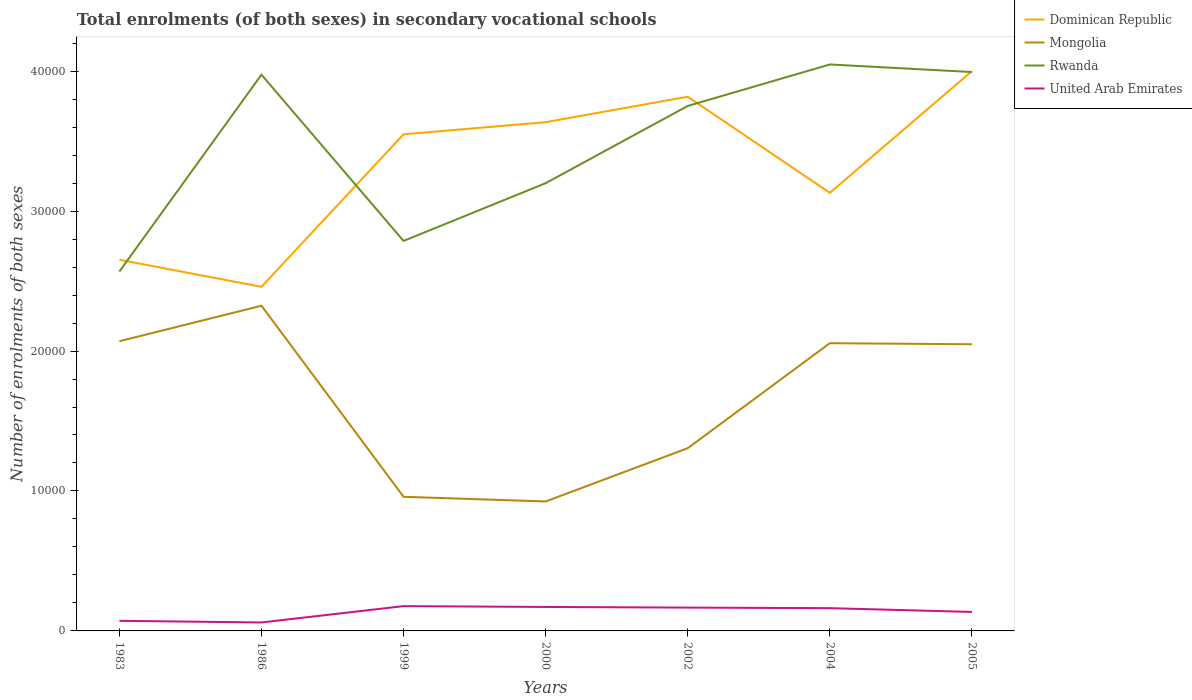How many different coloured lines are there?
Your answer should be very brief. 4. Is the number of lines equal to the number of legend labels?
Provide a short and direct response. Yes. Across all years, what is the maximum number of enrolments in secondary schools in Rwanda?
Offer a terse response. 2.57e+04. In which year was the number of enrolments in secondary schools in Rwanda maximum?
Give a very brief answer. 1983. What is the total number of enrolments in secondary schools in United Arab Emirates in the graph?
Your answer should be compact. 270. What is the difference between the highest and the second highest number of enrolments in secondary schools in Mongolia?
Make the answer very short. 1.40e+04. What is the difference between the highest and the lowest number of enrolments in secondary schools in Mongolia?
Your response must be concise. 4. How many lines are there?
Provide a succinct answer. 4. Are the values on the major ticks of Y-axis written in scientific E-notation?
Offer a terse response. No. Does the graph contain any zero values?
Keep it short and to the point. No. Where does the legend appear in the graph?
Give a very brief answer. Top right. How many legend labels are there?
Your answer should be compact. 4. How are the legend labels stacked?
Offer a terse response. Vertical. What is the title of the graph?
Your response must be concise. Total enrolments (of both sexes) in secondary vocational schools. What is the label or title of the X-axis?
Your answer should be compact. Years. What is the label or title of the Y-axis?
Provide a succinct answer. Number of enrolments of both sexes. What is the Number of enrolments of both sexes in Dominican Republic in 1983?
Give a very brief answer. 2.65e+04. What is the Number of enrolments of both sexes of Mongolia in 1983?
Make the answer very short. 2.07e+04. What is the Number of enrolments of both sexes of Rwanda in 1983?
Provide a short and direct response. 2.57e+04. What is the Number of enrolments of both sexes of United Arab Emirates in 1983?
Provide a succinct answer. 722. What is the Number of enrolments of both sexes of Dominican Republic in 1986?
Ensure brevity in your answer.  2.46e+04. What is the Number of enrolments of both sexes of Mongolia in 1986?
Your answer should be very brief. 2.32e+04. What is the Number of enrolments of both sexes in Rwanda in 1986?
Your response must be concise. 3.97e+04. What is the Number of enrolments of both sexes in United Arab Emirates in 1986?
Keep it short and to the point. 604. What is the Number of enrolments of both sexes in Dominican Republic in 1999?
Make the answer very short. 3.55e+04. What is the Number of enrolments of both sexes of Mongolia in 1999?
Your answer should be very brief. 9584. What is the Number of enrolments of both sexes of Rwanda in 1999?
Your answer should be very brief. 2.79e+04. What is the Number of enrolments of both sexes of United Arab Emirates in 1999?
Your answer should be compact. 1772. What is the Number of enrolments of both sexes in Dominican Republic in 2000?
Your response must be concise. 3.64e+04. What is the Number of enrolments of both sexes in Mongolia in 2000?
Keep it short and to the point. 9251. What is the Number of enrolments of both sexes in Rwanda in 2000?
Your answer should be very brief. 3.20e+04. What is the Number of enrolments of both sexes in United Arab Emirates in 2000?
Keep it short and to the point. 1713. What is the Number of enrolments of both sexes in Dominican Republic in 2002?
Your answer should be very brief. 3.82e+04. What is the Number of enrolments of both sexes of Mongolia in 2002?
Provide a succinct answer. 1.31e+04. What is the Number of enrolments of both sexes of Rwanda in 2002?
Keep it short and to the point. 3.75e+04. What is the Number of enrolments of both sexes in United Arab Emirates in 2002?
Ensure brevity in your answer.  1667. What is the Number of enrolments of both sexes in Dominican Republic in 2004?
Provide a succinct answer. 3.13e+04. What is the Number of enrolments of both sexes in Mongolia in 2004?
Offer a terse response. 2.06e+04. What is the Number of enrolments of both sexes in Rwanda in 2004?
Provide a short and direct response. 4.05e+04. What is the Number of enrolments of both sexes of United Arab Emirates in 2004?
Provide a succinct answer. 1627. What is the Number of enrolments of both sexes of Dominican Republic in 2005?
Make the answer very short. 4.00e+04. What is the Number of enrolments of both sexes of Mongolia in 2005?
Provide a short and direct response. 2.05e+04. What is the Number of enrolments of both sexes in Rwanda in 2005?
Offer a terse response. 3.99e+04. What is the Number of enrolments of both sexes in United Arab Emirates in 2005?
Offer a terse response. 1357. Across all years, what is the maximum Number of enrolments of both sexes in Dominican Republic?
Provide a short and direct response. 4.00e+04. Across all years, what is the maximum Number of enrolments of both sexes of Mongolia?
Offer a very short reply. 2.32e+04. Across all years, what is the maximum Number of enrolments of both sexes of Rwanda?
Make the answer very short. 4.05e+04. Across all years, what is the maximum Number of enrolments of both sexes of United Arab Emirates?
Provide a succinct answer. 1772. Across all years, what is the minimum Number of enrolments of both sexes of Dominican Republic?
Offer a terse response. 2.46e+04. Across all years, what is the minimum Number of enrolments of both sexes in Mongolia?
Your answer should be compact. 9251. Across all years, what is the minimum Number of enrolments of both sexes of Rwanda?
Offer a very short reply. 2.57e+04. Across all years, what is the minimum Number of enrolments of both sexes of United Arab Emirates?
Your response must be concise. 604. What is the total Number of enrolments of both sexes of Dominican Republic in the graph?
Ensure brevity in your answer.  2.32e+05. What is the total Number of enrolments of both sexes of Mongolia in the graph?
Your answer should be very brief. 1.17e+05. What is the total Number of enrolments of both sexes of Rwanda in the graph?
Provide a succinct answer. 2.43e+05. What is the total Number of enrolments of both sexes in United Arab Emirates in the graph?
Your answer should be compact. 9462. What is the difference between the Number of enrolments of both sexes of Dominican Republic in 1983 and that in 1986?
Your answer should be very brief. 1932. What is the difference between the Number of enrolments of both sexes in Mongolia in 1983 and that in 1986?
Ensure brevity in your answer.  -2536. What is the difference between the Number of enrolments of both sexes in Rwanda in 1983 and that in 1986?
Your answer should be compact. -1.41e+04. What is the difference between the Number of enrolments of both sexes of United Arab Emirates in 1983 and that in 1986?
Your response must be concise. 118. What is the difference between the Number of enrolments of both sexes of Dominican Republic in 1983 and that in 1999?
Make the answer very short. -8963. What is the difference between the Number of enrolments of both sexes of Mongolia in 1983 and that in 1999?
Keep it short and to the point. 1.11e+04. What is the difference between the Number of enrolments of both sexes of Rwanda in 1983 and that in 1999?
Make the answer very short. -2183. What is the difference between the Number of enrolments of both sexes of United Arab Emirates in 1983 and that in 1999?
Provide a short and direct response. -1050. What is the difference between the Number of enrolments of both sexes in Dominican Republic in 1983 and that in 2000?
Make the answer very short. -9831. What is the difference between the Number of enrolments of both sexes of Mongolia in 1983 and that in 2000?
Your answer should be very brief. 1.14e+04. What is the difference between the Number of enrolments of both sexes in Rwanda in 1983 and that in 2000?
Ensure brevity in your answer.  -6309. What is the difference between the Number of enrolments of both sexes of United Arab Emirates in 1983 and that in 2000?
Make the answer very short. -991. What is the difference between the Number of enrolments of both sexes of Dominican Republic in 1983 and that in 2002?
Your response must be concise. -1.17e+04. What is the difference between the Number of enrolments of both sexes of Mongolia in 1983 and that in 2002?
Provide a succinct answer. 7644. What is the difference between the Number of enrolments of both sexes of Rwanda in 1983 and that in 2002?
Keep it short and to the point. -1.18e+04. What is the difference between the Number of enrolments of both sexes of United Arab Emirates in 1983 and that in 2002?
Offer a terse response. -945. What is the difference between the Number of enrolments of both sexes of Dominican Republic in 1983 and that in 2004?
Offer a terse response. -4781. What is the difference between the Number of enrolments of both sexes in Mongolia in 1983 and that in 2004?
Offer a very short reply. 141. What is the difference between the Number of enrolments of both sexes in Rwanda in 1983 and that in 2004?
Offer a terse response. -1.48e+04. What is the difference between the Number of enrolments of both sexes of United Arab Emirates in 1983 and that in 2004?
Keep it short and to the point. -905. What is the difference between the Number of enrolments of both sexes of Dominican Republic in 1983 and that in 2005?
Provide a succinct answer. -1.35e+04. What is the difference between the Number of enrolments of both sexes of Mongolia in 1983 and that in 2005?
Provide a short and direct response. 216. What is the difference between the Number of enrolments of both sexes of Rwanda in 1983 and that in 2005?
Your answer should be compact. -1.43e+04. What is the difference between the Number of enrolments of both sexes of United Arab Emirates in 1983 and that in 2005?
Offer a terse response. -635. What is the difference between the Number of enrolments of both sexes in Dominican Republic in 1986 and that in 1999?
Give a very brief answer. -1.09e+04. What is the difference between the Number of enrolments of both sexes in Mongolia in 1986 and that in 1999?
Offer a terse response. 1.37e+04. What is the difference between the Number of enrolments of both sexes of Rwanda in 1986 and that in 1999?
Provide a short and direct response. 1.19e+04. What is the difference between the Number of enrolments of both sexes of United Arab Emirates in 1986 and that in 1999?
Your response must be concise. -1168. What is the difference between the Number of enrolments of both sexes in Dominican Republic in 1986 and that in 2000?
Ensure brevity in your answer.  -1.18e+04. What is the difference between the Number of enrolments of both sexes of Mongolia in 1986 and that in 2000?
Offer a very short reply. 1.40e+04. What is the difference between the Number of enrolments of both sexes in Rwanda in 1986 and that in 2000?
Provide a succinct answer. 7753. What is the difference between the Number of enrolments of both sexes of United Arab Emirates in 1986 and that in 2000?
Your response must be concise. -1109. What is the difference between the Number of enrolments of both sexes of Dominican Republic in 1986 and that in 2002?
Provide a short and direct response. -1.36e+04. What is the difference between the Number of enrolments of both sexes of Mongolia in 1986 and that in 2002?
Make the answer very short. 1.02e+04. What is the difference between the Number of enrolments of both sexes of Rwanda in 1986 and that in 2002?
Provide a succinct answer. 2234. What is the difference between the Number of enrolments of both sexes of United Arab Emirates in 1986 and that in 2002?
Give a very brief answer. -1063. What is the difference between the Number of enrolments of both sexes of Dominican Republic in 1986 and that in 2004?
Provide a short and direct response. -6713. What is the difference between the Number of enrolments of both sexes in Mongolia in 1986 and that in 2004?
Keep it short and to the point. 2677. What is the difference between the Number of enrolments of both sexes of Rwanda in 1986 and that in 2004?
Give a very brief answer. -729. What is the difference between the Number of enrolments of both sexes of United Arab Emirates in 1986 and that in 2004?
Offer a very short reply. -1023. What is the difference between the Number of enrolments of both sexes in Dominican Republic in 1986 and that in 2005?
Give a very brief answer. -1.54e+04. What is the difference between the Number of enrolments of both sexes in Mongolia in 1986 and that in 2005?
Make the answer very short. 2752. What is the difference between the Number of enrolments of both sexes in Rwanda in 1986 and that in 2005?
Ensure brevity in your answer.  -189. What is the difference between the Number of enrolments of both sexes of United Arab Emirates in 1986 and that in 2005?
Offer a very short reply. -753. What is the difference between the Number of enrolments of both sexes of Dominican Republic in 1999 and that in 2000?
Your answer should be very brief. -868. What is the difference between the Number of enrolments of both sexes in Mongolia in 1999 and that in 2000?
Offer a terse response. 333. What is the difference between the Number of enrolments of both sexes of Rwanda in 1999 and that in 2000?
Keep it short and to the point. -4126. What is the difference between the Number of enrolments of both sexes of Dominican Republic in 1999 and that in 2002?
Your answer should be compact. -2688. What is the difference between the Number of enrolments of both sexes of Mongolia in 1999 and that in 2002?
Offer a very short reply. -3472. What is the difference between the Number of enrolments of both sexes in Rwanda in 1999 and that in 2002?
Your answer should be very brief. -9645. What is the difference between the Number of enrolments of both sexes of United Arab Emirates in 1999 and that in 2002?
Make the answer very short. 105. What is the difference between the Number of enrolments of both sexes in Dominican Republic in 1999 and that in 2004?
Give a very brief answer. 4182. What is the difference between the Number of enrolments of both sexes in Mongolia in 1999 and that in 2004?
Provide a succinct answer. -1.10e+04. What is the difference between the Number of enrolments of both sexes in Rwanda in 1999 and that in 2004?
Keep it short and to the point. -1.26e+04. What is the difference between the Number of enrolments of both sexes of United Arab Emirates in 1999 and that in 2004?
Keep it short and to the point. 145. What is the difference between the Number of enrolments of both sexes of Dominican Republic in 1999 and that in 2005?
Your answer should be very brief. -4517. What is the difference between the Number of enrolments of both sexes of Mongolia in 1999 and that in 2005?
Provide a succinct answer. -1.09e+04. What is the difference between the Number of enrolments of both sexes in Rwanda in 1999 and that in 2005?
Keep it short and to the point. -1.21e+04. What is the difference between the Number of enrolments of both sexes of United Arab Emirates in 1999 and that in 2005?
Your answer should be very brief. 415. What is the difference between the Number of enrolments of both sexes of Dominican Republic in 2000 and that in 2002?
Make the answer very short. -1820. What is the difference between the Number of enrolments of both sexes in Mongolia in 2000 and that in 2002?
Give a very brief answer. -3805. What is the difference between the Number of enrolments of both sexes in Rwanda in 2000 and that in 2002?
Provide a short and direct response. -5519. What is the difference between the Number of enrolments of both sexes in United Arab Emirates in 2000 and that in 2002?
Keep it short and to the point. 46. What is the difference between the Number of enrolments of both sexes in Dominican Republic in 2000 and that in 2004?
Your response must be concise. 5050. What is the difference between the Number of enrolments of both sexes of Mongolia in 2000 and that in 2004?
Ensure brevity in your answer.  -1.13e+04. What is the difference between the Number of enrolments of both sexes of Rwanda in 2000 and that in 2004?
Your answer should be very brief. -8482. What is the difference between the Number of enrolments of both sexes of United Arab Emirates in 2000 and that in 2004?
Offer a terse response. 86. What is the difference between the Number of enrolments of both sexes in Dominican Republic in 2000 and that in 2005?
Offer a terse response. -3649. What is the difference between the Number of enrolments of both sexes of Mongolia in 2000 and that in 2005?
Provide a short and direct response. -1.12e+04. What is the difference between the Number of enrolments of both sexes of Rwanda in 2000 and that in 2005?
Provide a short and direct response. -7942. What is the difference between the Number of enrolments of both sexes in United Arab Emirates in 2000 and that in 2005?
Your answer should be very brief. 356. What is the difference between the Number of enrolments of both sexes of Dominican Republic in 2002 and that in 2004?
Your answer should be compact. 6870. What is the difference between the Number of enrolments of both sexes of Mongolia in 2002 and that in 2004?
Ensure brevity in your answer.  -7503. What is the difference between the Number of enrolments of both sexes in Rwanda in 2002 and that in 2004?
Give a very brief answer. -2963. What is the difference between the Number of enrolments of both sexes in Dominican Republic in 2002 and that in 2005?
Your answer should be very brief. -1829. What is the difference between the Number of enrolments of both sexes in Mongolia in 2002 and that in 2005?
Provide a short and direct response. -7428. What is the difference between the Number of enrolments of both sexes of Rwanda in 2002 and that in 2005?
Your answer should be very brief. -2423. What is the difference between the Number of enrolments of both sexes of United Arab Emirates in 2002 and that in 2005?
Provide a short and direct response. 310. What is the difference between the Number of enrolments of both sexes of Dominican Republic in 2004 and that in 2005?
Ensure brevity in your answer.  -8699. What is the difference between the Number of enrolments of both sexes of Rwanda in 2004 and that in 2005?
Give a very brief answer. 540. What is the difference between the Number of enrolments of both sexes in United Arab Emirates in 2004 and that in 2005?
Make the answer very short. 270. What is the difference between the Number of enrolments of both sexes of Dominican Republic in 1983 and the Number of enrolments of both sexes of Mongolia in 1986?
Offer a terse response. 3285. What is the difference between the Number of enrolments of both sexes in Dominican Republic in 1983 and the Number of enrolments of both sexes in Rwanda in 1986?
Your response must be concise. -1.32e+04. What is the difference between the Number of enrolments of both sexes in Dominican Republic in 1983 and the Number of enrolments of both sexes in United Arab Emirates in 1986?
Offer a terse response. 2.59e+04. What is the difference between the Number of enrolments of both sexes in Mongolia in 1983 and the Number of enrolments of both sexes in Rwanda in 1986?
Offer a very short reply. -1.90e+04. What is the difference between the Number of enrolments of both sexes in Mongolia in 1983 and the Number of enrolments of both sexes in United Arab Emirates in 1986?
Your answer should be very brief. 2.01e+04. What is the difference between the Number of enrolments of both sexes of Rwanda in 1983 and the Number of enrolments of both sexes of United Arab Emirates in 1986?
Offer a terse response. 2.51e+04. What is the difference between the Number of enrolments of both sexes of Dominican Republic in 1983 and the Number of enrolments of both sexes of Mongolia in 1999?
Keep it short and to the point. 1.69e+04. What is the difference between the Number of enrolments of both sexes of Dominican Republic in 1983 and the Number of enrolments of both sexes of Rwanda in 1999?
Keep it short and to the point. -1346. What is the difference between the Number of enrolments of both sexes of Dominican Republic in 1983 and the Number of enrolments of both sexes of United Arab Emirates in 1999?
Offer a very short reply. 2.47e+04. What is the difference between the Number of enrolments of both sexes of Mongolia in 1983 and the Number of enrolments of both sexes of Rwanda in 1999?
Ensure brevity in your answer.  -7167. What is the difference between the Number of enrolments of both sexes of Mongolia in 1983 and the Number of enrolments of both sexes of United Arab Emirates in 1999?
Keep it short and to the point. 1.89e+04. What is the difference between the Number of enrolments of both sexes of Rwanda in 1983 and the Number of enrolments of both sexes of United Arab Emirates in 1999?
Offer a very short reply. 2.39e+04. What is the difference between the Number of enrolments of both sexes of Dominican Republic in 1983 and the Number of enrolments of both sexes of Mongolia in 2000?
Your answer should be very brief. 1.73e+04. What is the difference between the Number of enrolments of both sexes of Dominican Republic in 1983 and the Number of enrolments of both sexes of Rwanda in 2000?
Your answer should be compact. -5472. What is the difference between the Number of enrolments of both sexes of Dominican Republic in 1983 and the Number of enrolments of both sexes of United Arab Emirates in 2000?
Ensure brevity in your answer.  2.48e+04. What is the difference between the Number of enrolments of both sexes of Mongolia in 1983 and the Number of enrolments of both sexes of Rwanda in 2000?
Give a very brief answer. -1.13e+04. What is the difference between the Number of enrolments of both sexes in Mongolia in 1983 and the Number of enrolments of both sexes in United Arab Emirates in 2000?
Offer a very short reply. 1.90e+04. What is the difference between the Number of enrolments of both sexes of Rwanda in 1983 and the Number of enrolments of both sexes of United Arab Emirates in 2000?
Keep it short and to the point. 2.40e+04. What is the difference between the Number of enrolments of both sexes in Dominican Republic in 1983 and the Number of enrolments of both sexes in Mongolia in 2002?
Provide a short and direct response. 1.35e+04. What is the difference between the Number of enrolments of both sexes of Dominican Republic in 1983 and the Number of enrolments of both sexes of Rwanda in 2002?
Offer a very short reply. -1.10e+04. What is the difference between the Number of enrolments of both sexes of Dominican Republic in 1983 and the Number of enrolments of both sexes of United Arab Emirates in 2002?
Keep it short and to the point. 2.49e+04. What is the difference between the Number of enrolments of both sexes in Mongolia in 1983 and the Number of enrolments of both sexes in Rwanda in 2002?
Make the answer very short. -1.68e+04. What is the difference between the Number of enrolments of both sexes in Mongolia in 1983 and the Number of enrolments of both sexes in United Arab Emirates in 2002?
Ensure brevity in your answer.  1.90e+04. What is the difference between the Number of enrolments of both sexes in Rwanda in 1983 and the Number of enrolments of both sexes in United Arab Emirates in 2002?
Your answer should be compact. 2.40e+04. What is the difference between the Number of enrolments of both sexes of Dominican Republic in 1983 and the Number of enrolments of both sexes of Mongolia in 2004?
Your answer should be compact. 5962. What is the difference between the Number of enrolments of both sexes in Dominican Republic in 1983 and the Number of enrolments of both sexes in Rwanda in 2004?
Offer a very short reply. -1.40e+04. What is the difference between the Number of enrolments of both sexes of Dominican Republic in 1983 and the Number of enrolments of both sexes of United Arab Emirates in 2004?
Offer a terse response. 2.49e+04. What is the difference between the Number of enrolments of both sexes of Mongolia in 1983 and the Number of enrolments of both sexes of Rwanda in 2004?
Your answer should be compact. -1.98e+04. What is the difference between the Number of enrolments of both sexes of Mongolia in 1983 and the Number of enrolments of both sexes of United Arab Emirates in 2004?
Your answer should be compact. 1.91e+04. What is the difference between the Number of enrolments of both sexes in Rwanda in 1983 and the Number of enrolments of both sexes in United Arab Emirates in 2004?
Keep it short and to the point. 2.41e+04. What is the difference between the Number of enrolments of both sexes in Dominican Republic in 1983 and the Number of enrolments of both sexes in Mongolia in 2005?
Provide a short and direct response. 6037. What is the difference between the Number of enrolments of both sexes in Dominican Republic in 1983 and the Number of enrolments of both sexes in Rwanda in 2005?
Offer a very short reply. -1.34e+04. What is the difference between the Number of enrolments of both sexes in Dominican Republic in 1983 and the Number of enrolments of both sexes in United Arab Emirates in 2005?
Your answer should be compact. 2.52e+04. What is the difference between the Number of enrolments of both sexes of Mongolia in 1983 and the Number of enrolments of both sexes of Rwanda in 2005?
Offer a terse response. -1.92e+04. What is the difference between the Number of enrolments of both sexes of Mongolia in 1983 and the Number of enrolments of both sexes of United Arab Emirates in 2005?
Your answer should be very brief. 1.93e+04. What is the difference between the Number of enrolments of both sexes of Rwanda in 1983 and the Number of enrolments of both sexes of United Arab Emirates in 2005?
Offer a very short reply. 2.43e+04. What is the difference between the Number of enrolments of both sexes in Dominican Republic in 1986 and the Number of enrolments of both sexes in Mongolia in 1999?
Provide a short and direct response. 1.50e+04. What is the difference between the Number of enrolments of both sexes of Dominican Republic in 1986 and the Number of enrolments of both sexes of Rwanda in 1999?
Your answer should be very brief. -3278. What is the difference between the Number of enrolments of both sexes of Dominican Republic in 1986 and the Number of enrolments of both sexes of United Arab Emirates in 1999?
Your answer should be compact. 2.28e+04. What is the difference between the Number of enrolments of both sexes in Mongolia in 1986 and the Number of enrolments of both sexes in Rwanda in 1999?
Keep it short and to the point. -4631. What is the difference between the Number of enrolments of both sexes of Mongolia in 1986 and the Number of enrolments of both sexes of United Arab Emirates in 1999?
Your response must be concise. 2.15e+04. What is the difference between the Number of enrolments of both sexes of Rwanda in 1986 and the Number of enrolments of both sexes of United Arab Emirates in 1999?
Provide a succinct answer. 3.80e+04. What is the difference between the Number of enrolments of both sexes of Dominican Republic in 1986 and the Number of enrolments of both sexes of Mongolia in 2000?
Your response must be concise. 1.53e+04. What is the difference between the Number of enrolments of both sexes in Dominican Republic in 1986 and the Number of enrolments of both sexes in Rwanda in 2000?
Provide a short and direct response. -7404. What is the difference between the Number of enrolments of both sexes in Dominican Republic in 1986 and the Number of enrolments of both sexes in United Arab Emirates in 2000?
Offer a terse response. 2.29e+04. What is the difference between the Number of enrolments of both sexes in Mongolia in 1986 and the Number of enrolments of both sexes in Rwanda in 2000?
Your response must be concise. -8757. What is the difference between the Number of enrolments of both sexes in Mongolia in 1986 and the Number of enrolments of both sexes in United Arab Emirates in 2000?
Provide a short and direct response. 2.15e+04. What is the difference between the Number of enrolments of both sexes in Rwanda in 1986 and the Number of enrolments of both sexes in United Arab Emirates in 2000?
Ensure brevity in your answer.  3.80e+04. What is the difference between the Number of enrolments of both sexes of Dominican Republic in 1986 and the Number of enrolments of both sexes of Mongolia in 2002?
Make the answer very short. 1.15e+04. What is the difference between the Number of enrolments of both sexes in Dominican Republic in 1986 and the Number of enrolments of both sexes in Rwanda in 2002?
Your answer should be very brief. -1.29e+04. What is the difference between the Number of enrolments of both sexes in Dominican Republic in 1986 and the Number of enrolments of both sexes in United Arab Emirates in 2002?
Keep it short and to the point. 2.29e+04. What is the difference between the Number of enrolments of both sexes of Mongolia in 1986 and the Number of enrolments of both sexes of Rwanda in 2002?
Offer a terse response. -1.43e+04. What is the difference between the Number of enrolments of both sexes in Mongolia in 1986 and the Number of enrolments of both sexes in United Arab Emirates in 2002?
Make the answer very short. 2.16e+04. What is the difference between the Number of enrolments of both sexes of Rwanda in 1986 and the Number of enrolments of both sexes of United Arab Emirates in 2002?
Your answer should be very brief. 3.81e+04. What is the difference between the Number of enrolments of both sexes of Dominican Republic in 1986 and the Number of enrolments of both sexes of Mongolia in 2004?
Provide a short and direct response. 4030. What is the difference between the Number of enrolments of both sexes in Dominican Republic in 1986 and the Number of enrolments of both sexes in Rwanda in 2004?
Your answer should be compact. -1.59e+04. What is the difference between the Number of enrolments of both sexes in Dominican Republic in 1986 and the Number of enrolments of both sexes in United Arab Emirates in 2004?
Your response must be concise. 2.30e+04. What is the difference between the Number of enrolments of both sexes of Mongolia in 1986 and the Number of enrolments of both sexes of Rwanda in 2004?
Your answer should be compact. -1.72e+04. What is the difference between the Number of enrolments of both sexes in Mongolia in 1986 and the Number of enrolments of both sexes in United Arab Emirates in 2004?
Give a very brief answer. 2.16e+04. What is the difference between the Number of enrolments of both sexes in Rwanda in 1986 and the Number of enrolments of both sexes in United Arab Emirates in 2004?
Keep it short and to the point. 3.81e+04. What is the difference between the Number of enrolments of both sexes in Dominican Republic in 1986 and the Number of enrolments of both sexes in Mongolia in 2005?
Your response must be concise. 4105. What is the difference between the Number of enrolments of both sexes of Dominican Republic in 1986 and the Number of enrolments of both sexes of Rwanda in 2005?
Give a very brief answer. -1.53e+04. What is the difference between the Number of enrolments of both sexes of Dominican Republic in 1986 and the Number of enrolments of both sexes of United Arab Emirates in 2005?
Your answer should be very brief. 2.32e+04. What is the difference between the Number of enrolments of both sexes of Mongolia in 1986 and the Number of enrolments of both sexes of Rwanda in 2005?
Your response must be concise. -1.67e+04. What is the difference between the Number of enrolments of both sexes in Mongolia in 1986 and the Number of enrolments of both sexes in United Arab Emirates in 2005?
Your answer should be very brief. 2.19e+04. What is the difference between the Number of enrolments of both sexes of Rwanda in 1986 and the Number of enrolments of both sexes of United Arab Emirates in 2005?
Your response must be concise. 3.84e+04. What is the difference between the Number of enrolments of both sexes in Dominican Republic in 1999 and the Number of enrolments of both sexes in Mongolia in 2000?
Ensure brevity in your answer.  2.62e+04. What is the difference between the Number of enrolments of both sexes in Dominican Republic in 1999 and the Number of enrolments of both sexes in Rwanda in 2000?
Give a very brief answer. 3491. What is the difference between the Number of enrolments of both sexes in Dominican Republic in 1999 and the Number of enrolments of both sexes in United Arab Emirates in 2000?
Offer a very short reply. 3.38e+04. What is the difference between the Number of enrolments of both sexes of Mongolia in 1999 and the Number of enrolments of both sexes of Rwanda in 2000?
Your response must be concise. -2.24e+04. What is the difference between the Number of enrolments of both sexes of Mongolia in 1999 and the Number of enrolments of both sexes of United Arab Emirates in 2000?
Your answer should be compact. 7871. What is the difference between the Number of enrolments of both sexes in Rwanda in 1999 and the Number of enrolments of both sexes in United Arab Emirates in 2000?
Give a very brief answer. 2.62e+04. What is the difference between the Number of enrolments of both sexes of Dominican Republic in 1999 and the Number of enrolments of both sexes of Mongolia in 2002?
Your answer should be very brief. 2.24e+04. What is the difference between the Number of enrolments of both sexes in Dominican Republic in 1999 and the Number of enrolments of both sexes in Rwanda in 2002?
Offer a very short reply. -2028. What is the difference between the Number of enrolments of both sexes in Dominican Republic in 1999 and the Number of enrolments of both sexes in United Arab Emirates in 2002?
Give a very brief answer. 3.38e+04. What is the difference between the Number of enrolments of both sexes in Mongolia in 1999 and the Number of enrolments of both sexes in Rwanda in 2002?
Give a very brief answer. -2.79e+04. What is the difference between the Number of enrolments of both sexes of Mongolia in 1999 and the Number of enrolments of both sexes of United Arab Emirates in 2002?
Your answer should be compact. 7917. What is the difference between the Number of enrolments of both sexes in Rwanda in 1999 and the Number of enrolments of both sexes in United Arab Emirates in 2002?
Provide a succinct answer. 2.62e+04. What is the difference between the Number of enrolments of both sexes of Dominican Republic in 1999 and the Number of enrolments of both sexes of Mongolia in 2004?
Ensure brevity in your answer.  1.49e+04. What is the difference between the Number of enrolments of both sexes in Dominican Republic in 1999 and the Number of enrolments of both sexes in Rwanda in 2004?
Your answer should be compact. -4991. What is the difference between the Number of enrolments of both sexes of Dominican Republic in 1999 and the Number of enrolments of both sexes of United Arab Emirates in 2004?
Your answer should be compact. 3.39e+04. What is the difference between the Number of enrolments of both sexes of Mongolia in 1999 and the Number of enrolments of both sexes of Rwanda in 2004?
Provide a succinct answer. -3.09e+04. What is the difference between the Number of enrolments of both sexes of Mongolia in 1999 and the Number of enrolments of both sexes of United Arab Emirates in 2004?
Your response must be concise. 7957. What is the difference between the Number of enrolments of both sexes in Rwanda in 1999 and the Number of enrolments of both sexes in United Arab Emirates in 2004?
Provide a short and direct response. 2.62e+04. What is the difference between the Number of enrolments of both sexes of Dominican Republic in 1999 and the Number of enrolments of both sexes of Mongolia in 2005?
Your answer should be very brief. 1.50e+04. What is the difference between the Number of enrolments of both sexes in Dominican Republic in 1999 and the Number of enrolments of both sexes in Rwanda in 2005?
Provide a short and direct response. -4451. What is the difference between the Number of enrolments of both sexes of Dominican Republic in 1999 and the Number of enrolments of both sexes of United Arab Emirates in 2005?
Offer a terse response. 3.41e+04. What is the difference between the Number of enrolments of both sexes of Mongolia in 1999 and the Number of enrolments of both sexes of Rwanda in 2005?
Offer a very short reply. -3.04e+04. What is the difference between the Number of enrolments of both sexes of Mongolia in 1999 and the Number of enrolments of both sexes of United Arab Emirates in 2005?
Your answer should be compact. 8227. What is the difference between the Number of enrolments of both sexes in Rwanda in 1999 and the Number of enrolments of both sexes in United Arab Emirates in 2005?
Offer a terse response. 2.65e+04. What is the difference between the Number of enrolments of both sexes of Dominican Republic in 2000 and the Number of enrolments of both sexes of Mongolia in 2002?
Provide a short and direct response. 2.33e+04. What is the difference between the Number of enrolments of both sexes in Dominican Republic in 2000 and the Number of enrolments of both sexes in Rwanda in 2002?
Ensure brevity in your answer.  -1160. What is the difference between the Number of enrolments of both sexes in Dominican Republic in 2000 and the Number of enrolments of both sexes in United Arab Emirates in 2002?
Make the answer very short. 3.47e+04. What is the difference between the Number of enrolments of both sexes of Mongolia in 2000 and the Number of enrolments of both sexes of Rwanda in 2002?
Make the answer very short. -2.83e+04. What is the difference between the Number of enrolments of both sexes in Mongolia in 2000 and the Number of enrolments of both sexes in United Arab Emirates in 2002?
Keep it short and to the point. 7584. What is the difference between the Number of enrolments of both sexes of Rwanda in 2000 and the Number of enrolments of both sexes of United Arab Emirates in 2002?
Your response must be concise. 3.03e+04. What is the difference between the Number of enrolments of both sexes in Dominican Republic in 2000 and the Number of enrolments of both sexes in Mongolia in 2004?
Keep it short and to the point. 1.58e+04. What is the difference between the Number of enrolments of both sexes of Dominican Republic in 2000 and the Number of enrolments of both sexes of Rwanda in 2004?
Provide a succinct answer. -4123. What is the difference between the Number of enrolments of both sexes in Dominican Republic in 2000 and the Number of enrolments of both sexes in United Arab Emirates in 2004?
Your response must be concise. 3.47e+04. What is the difference between the Number of enrolments of both sexes in Mongolia in 2000 and the Number of enrolments of both sexes in Rwanda in 2004?
Keep it short and to the point. -3.12e+04. What is the difference between the Number of enrolments of both sexes in Mongolia in 2000 and the Number of enrolments of both sexes in United Arab Emirates in 2004?
Offer a terse response. 7624. What is the difference between the Number of enrolments of both sexes in Rwanda in 2000 and the Number of enrolments of both sexes in United Arab Emirates in 2004?
Offer a terse response. 3.04e+04. What is the difference between the Number of enrolments of both sexes in Dominican Republic in 2000 and the Number of enrolments of both sexes in Mongolia in 2005?
Provide a succinct answer. 1.59e+04. What is the difference between the Number of enrolments of both sexes of Dominican Republic in 2000 and the Number of enrolments of both sexes of Rwanda in 2005?
Your response must be concise. -3583. What is the difference between the Number of enrolments of both sexes in Dominican Republic in 2000 and the Number of enrolments of both sexes in United Arab Emirates in 2005?
Ensure brevity in your answer.  3.50e+04. What is the difference between the Number of enrolments of both sexes of Mongolia in 2000 and the Number of enrolments of both sexes of Rwanda in 2005?
Your answer should be compact. -3.07e+04. What is the difference between the Number of enrolments of both sexes of Mongolia in 2000 and the Number of enrolments of both sexes of United Arab Emirates in 2005?
Your response must be concise. 7894. What is the difference between the Number of enrolments of both sexes of Rwanda in 2000 and the Number of enrolments of both sexes of United Arab Emirates in 2005?
Offer a terse response. 3.06e+04. What is the difference between the Number of enrolments of both sexes of Dominican Republic in 2002 and the Number of enrolments of both sexes of Mongolia in 2004?
Make the answer very short. 1.76e+04. What is the difference between the Number of enrolments of both sexes in Dominican Republic in 2002 and the Number of enrolments of both sexes in Rwanda in 2004?
Give a very brief answer. -2303. What is the difference between the Number of enrolments of both sexes of Dominican Republic in 2002 and the Number of enrolments of both sexes of United Arab Emirates in 2004?
Provide a short and direct response. 3.65e+04. What is the difference between the Number of enrolments of both sexes in Mongolia in 2002 and the Number of enrolments of both sexes in Rwanda in 2004?
Your answer should be very brief. -2.74e+04. What is the difference between the Number of enrolments of both sexes in Mongolia in 2002 and the Number of enrolments of both sexes in United Arab Emirates in 2004?
Keep it short and to the point. 1.14e+04. What is the difference between the Number of enrolments of both sexes of Rwanda in 2002 and the Number of enrolments of both sexes of United Arab Emirates in 2004?
Offer a terse response. 3.59e+04. What is the difference between the Number of enrolments of both sexes in Dominican Republic in 2002 and the Number of enrolments of both sexes in Mongolia in 2005?
Offer a very short reply. 1.77e+04. What is the difference between the Number of enrolments of both sexes in Dominican Republic in 2002 and the Number of enrolments of both sexes in Rwanda in 2005?
Keep it short and to the point. -1763. What is the difference between the Number of enrolments of both sexes of Dominican Republic in 2002 and the Number of enrolments of both sexes of United Arab Emirates in 2005?
Give a very brief answer. 3.68e+04. What is the difference between the Number of enrolments of both sexes in Mongolia in 2002 and the Number of enrolments of both sexes in Rwanda in 2005?
Keep it short and to the point. -2.69e+04. What is the difference between the Number of enrolments of both sexes in Mongolia in 2002 and the Number of enrolments of both sexes in United Arab Emirates in 2005?
Offer a very short reply. 1.17e+04. What is the difference between the Number of enrolments of both sexes in Rwanda in 2002 and the Number of enrolments of both sexes in United Arab Emirates in 2005?
Keep it short and to the point. 3.62e+04. What is the difference between the Number of enrolments of both sexes of Dominican Republic in 2004 and the Number of enrolments of both sexes of Mongolia in 2005?
Your answer should be very brief. 1.08e+04. What is the difference between the Number of enrolments of both sexes of Dominican Republic in 2004 and the Number of enrolments of both sexes of Rwanda in 2005?
Keep it short and to the point. -8633. What is the difference between the Number of enrolments of both sexes of Dominican Republic in 2004 and the Number of enrolments of both sexes of United Arab Emirates in 2005?
Keep it short and to the point. 2.99e+04. What is the difference between the Number of enrolments of both sexes in Mongolia in 2004 and the Number of enrolments of both sexes in Rwanda in 2005?
Ensure brevity in your answer.  -1.94e+04. What is the difference between the Number of enrolments of both sexes of Mongolia in 2004 and the Number of enrolments of both sexes of United Arab Emirates in 2005?
Provide a short and direct response. 1.92e+04. What is the difference between the Number of enrolments of both sexes of Rwanda in 2004 and the Number of enrolments of both sexes of United Arab Emirates in 2005?
Make the answer very short. 3.91e+04. What is the average Number of enrolments of both sexes in Dominican Republic per year?
Your answer should be very brief. 3.32e+04. What is the average Number of enrolments of both sexes of Mongolia per year?
Ensure brevity in your answer.  1.67e+04. What is the average Number of enrolments of both sexes in Rwanda per year?
Offer a very short reply. 3.47e+04. What is the average Number of enrolments of both sexes of United Arab Emirates per year?
Offer a very short reply. 1351.71. In the year 1983, what is the difference between the Number of enrolments of both sexes of Dominican Republic and Number of enrolments of both sexes of Mongolia?
Your answer should be very brief. 5821. In the year 1983, what is the difference between the Number of enrolments of both sexes in Dominican Republic and Number of enrolments of both sexes in Rwanda?
Keep it short and to the point. 837. In the year 1983, what is the difference between the Number of enrolments of both sexes of Dominican Republic and Number of enrolments of both sexes of United Arab Emirates?
Your response must be concise. 2.58e+04. In the year 1983, what is the difference between the Number of enrolments of both sexes in Mongolia and Number of enrolments of both sexes in Rwanda?
Offer a terse response. -4984. In the year 1983, what is the difference between the Number of enrolments of both sexes of Mongolia and Number of enrolments of both sexes of United Arab Emirates?
Provide a succinct answer. 2.00e+04. In the year 1983, what is the difference between the Number of enrolments of both sexes in Rwanda and Number of enrolments of both sexes in United Arab Emirates?
Your answer should be compact. 2.50e+04. In the year 1986, what is the difference between the Number of enrolments of both sexes of Dominican Republic and Number of enrolments of both sexes of Mongolia?
Offer a very short reply. 1353. In the year 1986, what is the difference between the Number of enrolments of both sexes of Dominican Republic and Number of enrolments of both sexes of Rwanda?
Make the answer very short. -1.52e+04. In the year 1986, what is the difference between the Number of enrolments of both sexes of Dominican Republic and Number of enrolments of both sexes of United Arab Emirates?
Your answer should be compact. 2.40e+04. In the year 1986, what is the difference between the Number of enrolments of both sexes of Mongolia and Number of enrolments of both sexes of Rwanda?
Offer a terse response. -1.65e+04. In the year 1986, what is the difference between the Number of enrolments of both sexes in Mongolia and Number of enrolments of both sexes in United Arab Emirates?
Your answer should be compact. 2.26e+04. In the year 1986, what is the difference between the Number of enrolments of both sexes of Rwanda and Number of enrolments of both sexes of United Arab Emirates?
Keep it short and to the point. 3.91e+04. In the year 1999, what is the difference between the Number of enrolments of both sexes in Dominican Republic and Number of enrolments of both sexes in Mongolia?
Offer a very short reply. 2.59e+04. In the year 1999, what is the difference between the Number of enrolments of both sexes in Dominican Republic and Number of enrolments of both sexes in Rwanda?
Give a very brief answer. 7617. In the year 1999, what is the difference between the Number of enrolments of both sexes in Dominican Republic and Number of enrolments of both sexes in United Arab Emirates?
Ensure brevity in your answer.  3.37e+04. In the year 1999, what is the difference between the Number of enrolments of both sexes in Mongolia and Number of enrolments of both sexes in Rwanda?
Your response must be concise. -1.83e+04. In the year 1999, what is the difference between the Number of enrolments of both sexes of Mongolia and Number of enrolments of both sexes of United Arab Emirates?
Provide a short and direct response. 7812. In the year 1999, what is the difference between the Number of enrolments of both sexes in Rwanda and Number of enrolments of both sexes in United Arab Emirates?
Ensure brevity in your answer.  2.61e+04. In the year 2000, what is the difference between the Number of enrolments of both sexes in Dominican Republic and Number of enrolments of both sexes in Mongolia?
Offer a terse response. 2.71e+04. In the year 2000, what is the difference between the Number of enrolments of both sexes in Dominican Republic and Number of enrolments of both sexes in Rwanda?
Offer a terse response. 4359. In the year 2000, what is the difference between the Number of enrolments of both sexes in Dominican Republic and Number of enrolments of both sexes in United Arab Emirates?
Offer a terse response. 3.46e+04. In the year 2000, what is the difference between the Number of enrolments of both sexes in Mongolia and Number of enrolments of both sexes in Rwanda?
Keep it short and to the point. -2.27e+04. In the year 2000, what is the difference between the Number of enrolments of both sexes in Mongolia and Number of enrolments of both sexes in United Arab Emirates?
Make the answer very short. 7538. In the year 2000, what is the difference between the Number of enrolments of both sexes in Rwanda and Number of enrolments of both sexes in United Arab Emirates?
Keep it short and to the point. 3.03e+04. In the year 2002, what is the difference between the Number of enrolments of both sexes in Dominican Republic and Number of enrolments of both sexes in Mongolia?
Your answer should be very brief. 2.51e+04. In the year 2002, what is the difference between the Number of enrolments of both sexes in Dominican Republic and Number of enrolments of both sexes in Rwanda?
Offer a very short reply. 660. In the year 2002, what is the difference between the Number of enrolments of both sexes of Dominican Republic and Number of enrolments of both sexes of United Arab Emirates?
Your answer should be compact. 3.65e+04. In the year 2002, what is the difference between the Number of enrolments of both sexes in Mongolia and Number of enrolments of both sexes in Rwanda?
Give a very brief answer. -2.45e+04. In the year 2002, what is the difference between the Number of enrolments of both sexes of Mongolia and Number of enrolments of both sexes of United Arab Emirates?
Make the answer very short. 1.14e+04. In the year 2002, what is the difference between the Number of enrolments of both sexes of Rwanda and Number of enrolments of both sexes of United Arab Emirates?
Your response must be concise. 3.58e+04. In the year 2004, what is the difference between the Number of enrolments of both sexes of Dominican Republic and Number of enrolments of both sexes of Mongolia?
Offer a very short reply. 1.07e+04. In the year 2004, what is the difference between the Number of enrolments of both sexes of Dominican Republic and Number of enrolments of both sexes of Rwanda?
Your response must be concise. -9173. In the year 2004, what is the difference between the Number of enrolments of both sexes in Dominican Republic and Number of enrolments of both sexes in United Arab Emirates?
Keep it short and to the point. 2.97e+04. In the year 2004, what is the difference between the Number of enrolments of both sexes of Mongolia and Number of enrolments of both sexes of Rwanda?
Your answer should be very brief. -1.99e+04. In the year 2004, what is the difference between the Number of enrolments of both sexes of Mongolia and Number of enrolments of both sexes of United Arab Emirates?
Give a very brief answer. 1.89e+04. In the year 2004, what is the difference between the Number of enrolments of both sexes in Rwanda and Number of enrolments of both sexes in United Arab Emirates?
Give a very brief answer. 3.88e+04. In the year 2005, what is the difference between the Number of enrolments of both sexes of Dominican Republic and Number of enrolments of both sexes of Mongolia?
Keep it short and to the point. 1.95e+04. In the year 2005, what is the difference between the Number of enrolments of both sexes of Dominican Republic and Number of enrolments of both sexes of Rwanda?
Offer a terse response. 66. In the year 2005, what is the difference between the Number of enrolments of both sexes in Dominican Republic and Number of enrolments of both sexes in United Arab Emirates?
Your answer should be very brief. 3.86e+04. In the year 2005, what is the difference between the Number of enrolments of both sexes of Mongolia and Number of enrolments of both sexes of Rwanda?
Your answer should be very brief. -1.95e+04. In the year 2005, what is the difference between the Number of enrolments of both sexes of Mongolia and Number of enrolments of both sexes of United Arab Emirates?
Provide a succinct answer. 1.91e+04. In the year 2005, what is the difference between the Number of enrolments of both sexes of Rwanda and Number of enrolments of both sexes of United Arab Emirates?
Provide a short and direct response. 3.86e+04. What is the ratio of the Number of enrolments of both sexes in Dominican Republic in 1983 to that in 1986?
Your response must be concise. 1.08. What is the ratio of the Number of enrolments of both sexes of Mongolia in 1983 to that in 1986?
Offer a very short reply. 0.89. What is the ratio of the Number of enrolments of both sexes in Rwanda in 1983 to that in 1986?
Ensure brevity in your answer.  0.65. What is the ratio of the Number of enrolments of both sexes in United Arab Emirates in 1983 to that in 1986?
Your answer should be very brief. 1.2. What is the ratio of the Number of enrolments of both sexes in Dominican Republic in 1983 to that in 1999?
Make the answer very short. 0.75. What is the ratio of the Number of enrolments of both sexes of Mongolia in 1983 to that in 1999?
Offer a terse response. 2.16. What is the ratio of the Number of enrolments of both sexes in Rwanda in 1983 to that in 1999?
Provide a short and direct response. 0.92. What is the ratio of the Number of enrolments of both sexes in United Arab Emirates in 1983 to that in 1999?
Offer a very short reply. 0.41. What is the ratio of the Number of enrolments of both sexes in Dominican Republic in 1983 to that in 2000?
Offer a terse response. 0.73. What is the ratio of the Number of enrolments of both sexes of Mongolia in 1983 to that in 2000?
Provide a short and direct response. 2.24. What is the ratio of the Number of enrolments of both sexes in Rwanda in 1983 to that in 2000?
Give a very brief answer. 0.8. What is the ratio of the Number of enrolments of both sexes in United Arab Emirates in 1983 to that in 2000?
Your answer should be very brief. 0.42. What is the ratio of the Number of enrolments of both sexes of Dominican Republic in 1983 to that in 2002?
Your response must be concise. 0.69. What is the ratio of the Number of enrolments of both sexes of Mongolia in 1983 to that in 2002?
Ensure brevity in your answer.  1.59. What is the ratio of the Number of enrolments of both sexes of Rwanda in 1983 to that in 2002?
Give a very brief answer. 0.68. What is the ratio of the Number of enrolments of both sexes of United Arab Emirates in 1983 to that in 2002?
Your answer should be very brief. 0.43. What is the ratio of the Number of enrolments of both sexes in Dominican Republic in 1983 to that in 2004?
Your answer should be compact. 0.85. What is the ratio of the Number of enrolments of both sexes of Mongolia in 1983 to that in 2004?
Offer a very short reply. 1.01. What is the ratio of the Number of enrolments of both sexes of Rwanda in 1983 to that in 2004?
Your answer should be compact. 0.63. What is the ratio of the Number of enrolments of both sexes in United Arab Emirates in 1983 to that in 2004?
Keep it short and to the point. 0.44. What is the ratio of the Number of enrolments of both sexes in Dominican Republic in 1983 to that in 2005?
Your answer should be compact. 0.66. What is the ratio of the Number of enrolments of both sexes in Mongolia in 1983 to that in 2005?
Your answer should be very brief. 1.01. What is the ratio of the Number of enrolments of both sexes of Rwanda in 1983 to that in 2005?
Provide a short and direct response. 0.64. What is the ratio of the Number of enrolments of both sexes in United Arab Emirates in 1983 to that in 2005?
Give a very brief answer. 0.53. What is the ratio of the Number of enrolments of both sexes in Dominican Republic in 1986 to that in 1999?
Ensure brevity in your answer.  0.69. What is the ratio of the Number of enrolments of both sexes of Mongolia in 1986 to that in 1999?
Offer a terse response. 2.42. What is the ratio of the Number of enrolments of both sexes in Rwanda in 1986 to that in 1999?
Offer a very short reply. 1.43. What is the ratio of the Number of enrolments of both sexes of United Arab Emirates in 1986 to that in 1999?
Your answer should be compact. 0.34. What is the ratio of the Number of enrolments of both sexes of Dominican Republic in 1986 to that in 2000?
Your answer should be very brief. 0.68. What is the ratio of the Number of enrolments of both sexes of Mongolia in 1986 to that in 2000?
Offer a very short reply. 2.51. What is the ratio of the Number of enrolments of both sexes of Rwanda in 1986 to that in 2000?
Keep it short and to the point. 1.24. What is the ratio of the Number of enrolments of both sexes of United Arab Emirates in 1986 to that in 2000?
Your answer should be very brief. 0.35. What is the ratio of the Number of enrolments of both sexes in Dominican Republic in 1986 to that in 2002?
Your response must be concise. 0.64. What is the ratio of the Number of enrolments of both sexes of Mongolia in 1986 to that in 2002?
Make the answer very short. 1.78. What is the ratio of the Number of enrolments of both sexes in Rwanda in 1986 to that in 2002?
Keep it short and to the point. 1.06. What is the ratio of the Number of enrolments of both sexes in United Arab Emirates in 1986 to that in 2002?
Ensure brevity in your answer.  0.36. What is the ratio of the Number of enrolments of both sexes of Dominican Republic in 1986 to that in 2004?
Offer a very short reply. 0.79. What is the ratio of the Number of enrolments of both sexes of Mongolia in 1986 to that in 2004?
Your answer should be very brief. 1.13. What is the ratio of the Number of enrolments of both sexes of United Arab Emirates in 1986 to that in 2004?
Offer a terse response. 0.37. What is the ratio of the Number of enrolments of both sexes in Dominican Republic in 1986 to that in 2005?
Give a very brief answer. 0.61. What is the ratio of the Number of enrolments of both sexes in Mongolia in 1986 to that in 2005?
Your answer should be very brief. 1.13. What is the ratio of the Number of enrolments of both sexes in Rwanda in 1986 to that in 2005?
Ensure brevity in your answer.  1. What is the ratio of the Number of enrolments of both sexes of United Arab Emirates in 1986 to that in 2005?
Make the answer very short. 0.45. What is the ratio of the Number of enrolments of both sexes in Dominican Republic in 1999 to that in 2000?
Your response must be concise. 0.98. What is the ratio of the Number of enrolments of both sexes in Mongolia in 1999 to that in 2000?
Offer a very short reply. 1.04. What is the ratio of the Number of enrolments of both sexes in Rwanda in 1999 to that in 2000?
Your response must be concise. 0.87. What is the ratio of the Number of enrolments of both sexes in United Arab Emirates in 1999 to that in 2000?
Offer a terse response. 1.03. What is the ratio of the Number of enrolments of both sexes in Dominican Republic in 1999 to that in 2002?
Your response must be concise. 0.93. What is the ratio of the Number of enrolments of both sexes of Mongolia in 1999 to that in 2002?
Your answer should be very brief. 0.73. What is the ratio of the Number of enrolments of both sexes in Rwanda in 1999 to that in 2002?
Your response must be concise. 0.74. What is the ratio of the Number of enrolments of both sexes in United Arab Emirates in 1999 to that in 2002?
Make the answer very short. 1.06. What is the ratio of the Number of enrolments of both sexes in Dominican Republic in 1999 to that in 2004?
Your response must be concise. 1.13. What is the ratio of the Number of enrolments of both sexes in Mongolia in 1999 to that in 2004?
Provide a short and direct response. 0.47. What is the ratio of the Number of enrolments of both sexes in Rwanda in 1999 to that in 2004?
Provide a short and direct response. 0.69. What is the ratio of the Number of enrolments of both sexes in United Arab Emirates in 1999 to that in 2004?
Make the answer very short. 1.09. What is the ratio of the Number of enrolments of both sexes of Dominican Republic in 1999 to that in 2005?
Provide a short and direct response. 0.89. What is the ratio of the Number of enrolments of both sexes of Mongolia in 1999 to that in 2005?
Make the answer very short. 0.47. What is the ratio of the Number of enrolments of both sexes of Rwanda in 1999 to that in 2005?
Your answer should be very brief. 0.7. What is the ratio of the Number of enrolments of both sexes in United Arab Emirates in 1999 to that in 2005?
Ensure brevity in your answer.  1.31. What is the ratio of the Number of enrolments of both sexes of Dominican Republic in 2000 to that in 2002?
Keep it short and to the point. 0.95. What is the ratio of the Number of enrolments of both sexes of Mongolia in 2000 to that in 2002?
Provide a short and direct response. 0.71. What is the ratio of the Number of enrolments of both sexes of Rwanda in 2000 to that in 2002?
Offer a terse response. 0.85. What is the ratio of the Number of enrolments of both sexes in United Arab Emirates in 2000 to that in 2002?
Your answer should be compact. 1.03. What is the ratio of the Number of enrolments of both sexes in Dominican Republic in 2000 to that in 2004?
Your answer should be very brief. 1.16. What is the ratio of the Number of enrolments of both sexes of Mongolia in 2000 to that in 2004?
Offer a very short reply. 0.45. What is the ratio of the Number of enrolments of both sexes of Rwanda in 2000 to that in 2004?
Keep it short and to the point. 0.79. What is the ratio of the Number of enrolments of both sexes of United Arab Emirates in 2000 to that in 2004?
Make the answer very short. 1.05. What is the ratio of the Number of enrolments of both sexes of Dominican Republic in 2000 to that in 2005?
Offer a very short reply. 0.91. What is the ratio of the Number of enrolments of both sexes in Mongolia in 2000 to that in 2005?
Ensure brevity in your answer.  0.45. What is the ratio of the Number of enrolments of both sexes in Rwanda in 2000 to that in 2005?
Keep it short and to the point. 0.8. What is the ratio of the Number of enrolments of both sexes of United Arab Emirates in 2000 to that in 2005?
Your response must be concise. 1.26. What is the ratio of the Number of enrolments of both sexes of Dominican Republic in 2002 to that in 2004?
Provide a succinct answer. 1.22. What is the ratio of the Number of enrolments of both sexes in Mongolia in 2002 to that in 2004?
Your response must be concise. 0.64. What is the ratio of the Number of enrolments of both sexes in Rwanda in 2002 to that in 2004?
Your response must be concise. 0.93. What is the ratio of the Number of enrolments of both sexes in United Arab Emirates in 2002 to that in 2004?
Give a very brief answer. 1.02. What is the ratio of the Number of enrolments of both sexes in Dominican Republic in 2002 to that in 2005?
Offer a terse response. 0.95. What is the ratio of the Number of enrolments of both sexes in Mongolia in 2002 to that in 2005?
Give a very brief answer. 0.64. What is the ratio of the Number of enrolments of both sexes in Rwanda in 2002 to that in 2005?
Offer a very short reply. 0.94. What is the ratio of the Number of enrolments of both sexes in United Arab Emirates in 2002 to that in 2005?
Provide a succinct answer. 1.23. What is the ratio of the Number of enrolments of both sexes of Dominican Republic in 2004 to that in 2005?
Your response must be concise. 0.78. What is the ratio of the Number of enrolments of both sexes in Mongolia in 2004 to that in 2005?
Provide a short and direct response. 1. What is the ratio of the Number of enrolments of both sexes in Rwanda in 2004 to that in 2005?
Provide a succinct answer. 1.01. What is the ratio of the Number of enrolments of both sexes in United Arab Emirates in 2004 to that in 2005?
Make the answer very short. 1.2. What is the difference between the highest and the second highest Number of enrolments of both sexes in Dominican Republic?
Your response must be concise. 1829. What is the difference between the highest and the second highest Number of enrolments of both sexes of Mongolia?
Your response must be concise. 2536. What is the difference between the highest and the second highest Number of enrolments of both sexes of Rwanda?
Make the answer very short. 540. What is the difference between the highest and the second highest Number of enrolments of both sexes of United Arab Emirates?
Your response must be concise. 59. What is the difference between the highest and the lowest Number of enrolments of both sexes in Dominican Republic?
Provide a succinct answer. 1.54e+04. What is the difference between the highest and the lowest Number of enrolments of both sexes of Mongolia?
Give a very brief answer. 1.40e+04. What is the difference between the highest and the lowest Number of enrolments of both sexes of Rwanda?
Provide a short and direct response. 1.48e+04. What is the difference between the highest and the lowest Number of enrolments of both sexes in United Arab Emirates?
Your response must be concise. 1168. 